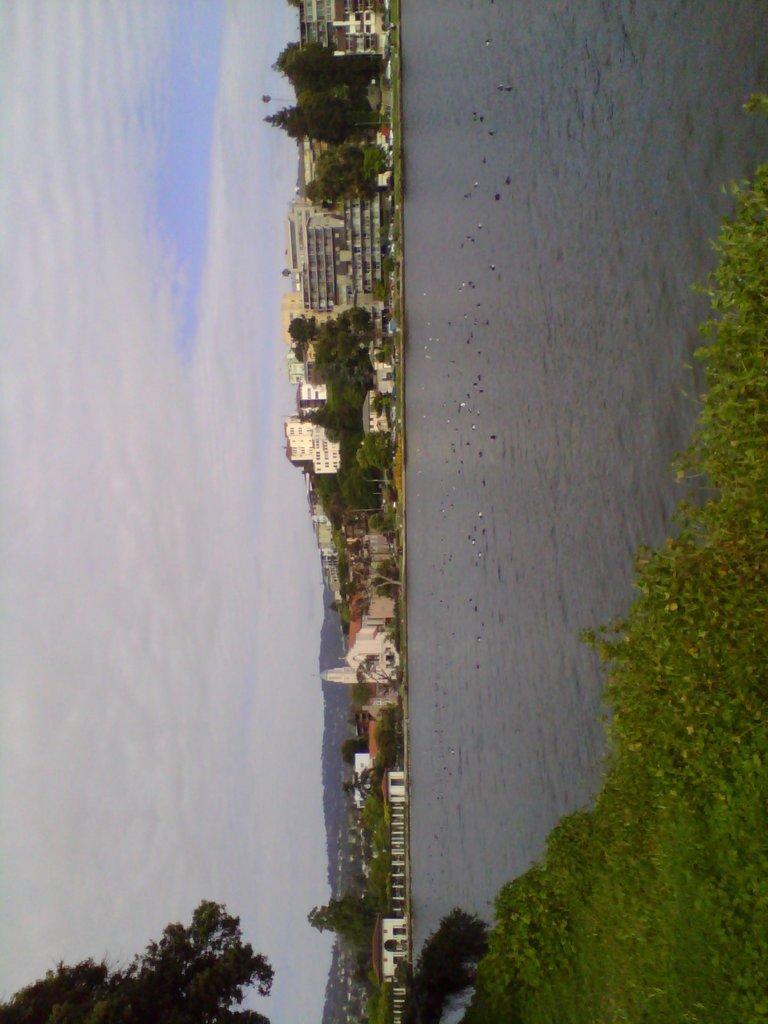Describe this image in one or two sentences. These are the buildings with the windows. I can see the trees. This is the grass. I think these are the birds flying. Here is the water. This is the sky. 